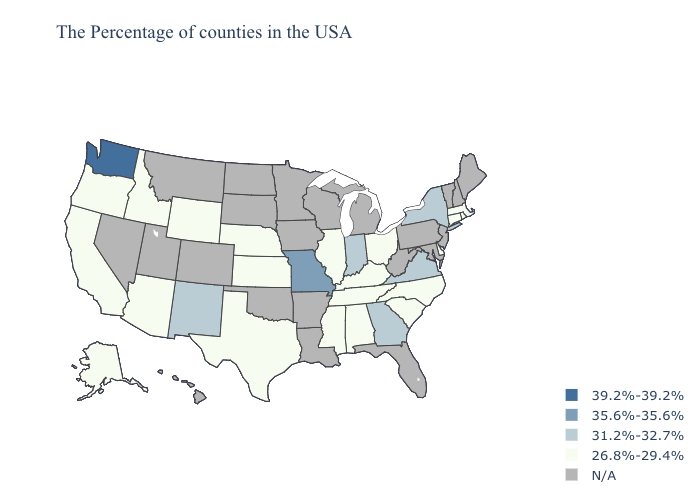Name the states that have a value in the range 35.6%-35.6%?
Answer briefly. Missouri. What is the highest value in the USA?
Concise answer only. 39.2%-39.2%. Does Kentucky have the highest value in the South?
Quick response, please. No. Which states hav the highest value in the Northeast?
Give a very brief answer. New York. What is the value of Hawaii?
Be succinct. N/A. Name the states that have a value in the range 31.2%-32.7%?
Be succinct. New York, Virginia, Georgia, Indiana, New Mexico. Does South Carolina have the highest value in the USA?
Answer briefly. No. What is the highest value in states that border New Hampshire?
Quick response, please. 26.8%-29.4%. Name the states that have a value in the range N/A?
Short answer required. Maine, New Hampshire, Vermont, New Jersey, Maryland, Pennsylvania, West Virginia, Florida, Michigan, Wisconsin, Louisiana, Arkansas, Minnesota, Iowa, Oklahoma, South Dakota, North Dakota, Colorado, Utah, Montana, Nevada, Hawaii. What is the value of Connecticut?
Write a very short answer. 26.8%-29.4%. Among the states that border Illinois , does Kentucky have the lowest value?
Short answer required. Yes. Name the states that have a value in the range 26.8%-29.4%?
Concise answer only. Massachusetts, Rhode Island, Connecticut, Delaware, North Carolina, South Carolina, Ohio, Kentucky, Alabama, Tennessee, Illinois, Mississippi, Kansas, Nebraska, Texas, Wyoming, Arizona, Idaho, California, Oregon, Alaska. What is the value of Tennessee?
Write a very short answer. 26.8%-29.4%. What is the value of Mississippi?
Be succinct. 26.8%-29.4%. 